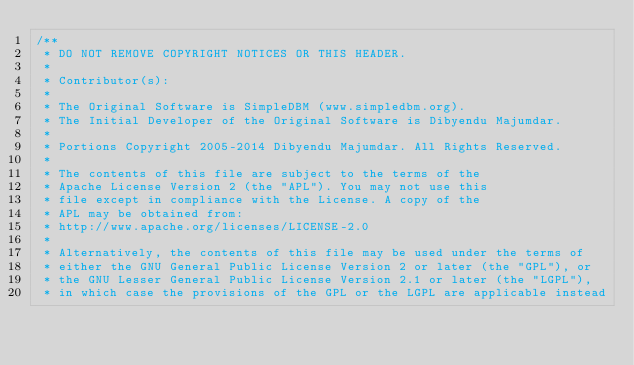<code> <loc_0><loc_0><loc_500><loc_500><_Java_>/**
 * DO NOT REMOVE COPYRIGHT NOTICES OR THIS HEADER.
 *
 * Contributor(s):
 *
 * The Original Software is SimpleDBM (www.simpledbm.org).
 * The Initial Developer of the Original Software is Dibyendu Majumdar.
 *
 * Portions Copyright 2005-2014 Dibyendu Majumdar. All Rights Reserved.
 *
 * The contents of this file are subject to the terms of the
 * Apache License Version 2 (the "APL"). You may not use this
 * file except in compliance with the License. A copy of the
 * APL may be obtained from:
 * http://www.apache.org/licenses/LICENSE-2.0
 *
 * Alternatively, the contents of this file may be used under the terms of
 * either the GNU General Public License Version 2 or later (the "GPL"), or
 * the GNU Lesser General Public License Version 2.1 or later (the "LGPL"),
 * in which case the provisions of the GPL or the LGPL are applicable instead</code> 